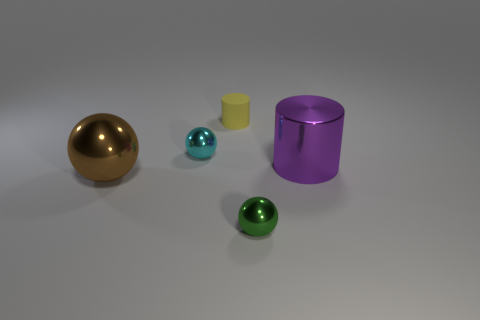Subtract all tiny metal spheres. How many spheres are left? 1 Add 2 small balls. How many objects exist? 7 Subtract all cylinders. How many objects are left? 3 Add 5 small yellow objects. How many small yellow objects exist? 6 Subtract 0 green blocks. How many objects are left? 5 Subtract all yellow things. Subtract all large green matte blocks. How many objects are left? 4 Add 1 big metal things. How many big metal things are left? 3 